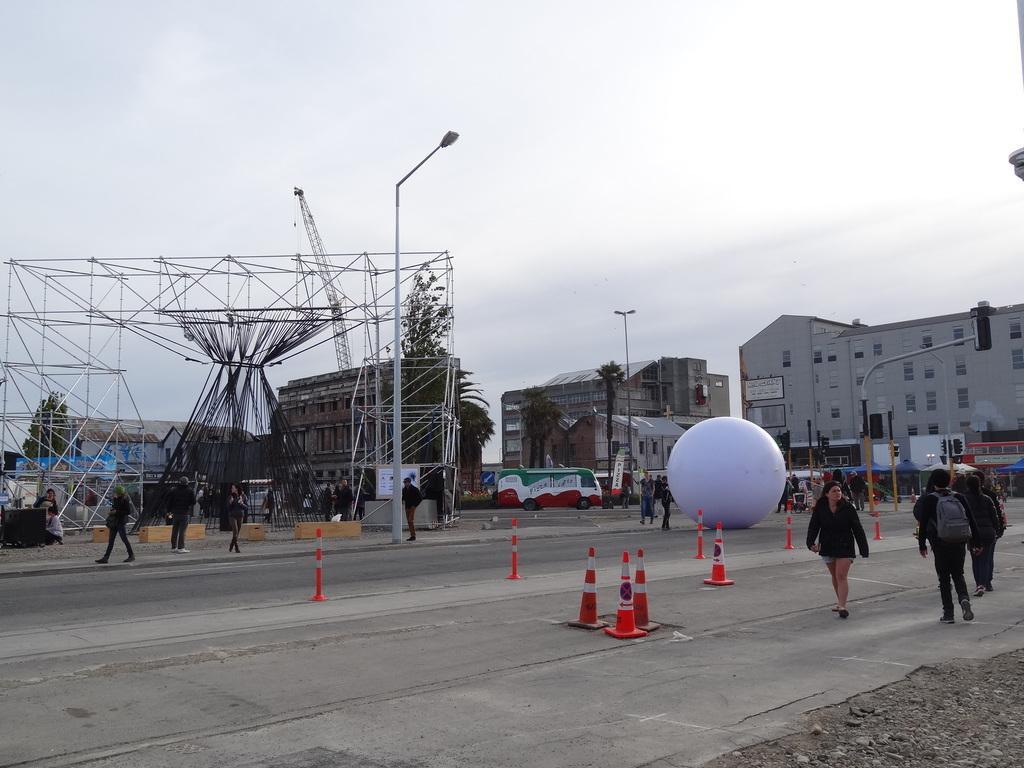Please provide a concise description of this image. There is a group of people, a vehicle and a ball is present on the road as we can see at the bottom of this image. There are trees and buildings in the background. The sky is at the top of this image. 